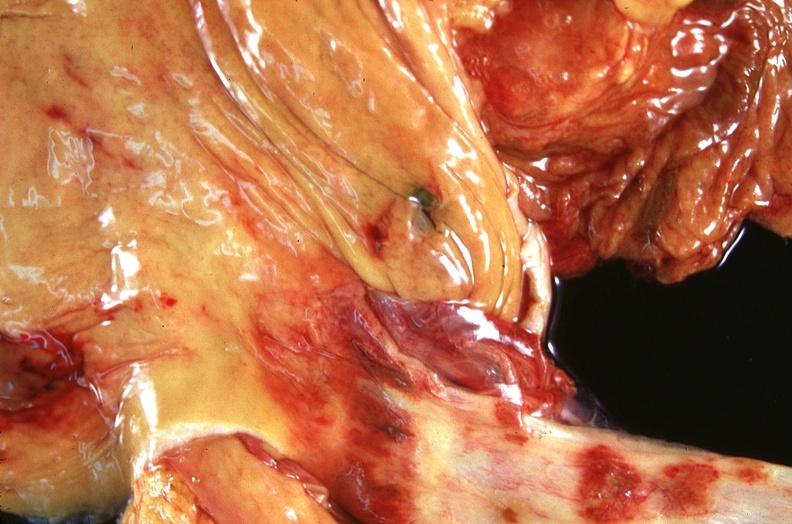where does this belong to?
Answer the question using a single word or phrase. Gastrointestinal system 